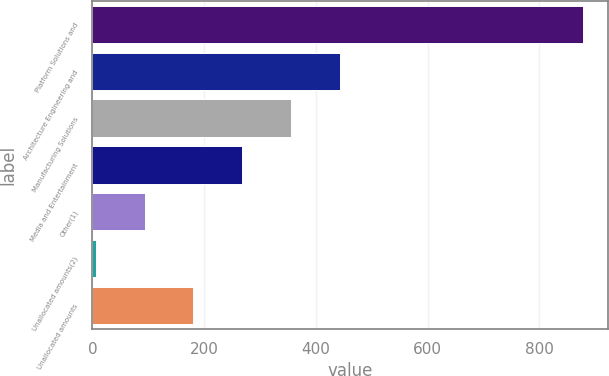<chart> <loc_0><loc_0><loc_500><loc_500><bar_chart><fcel>Platform Solutions and<fcel>Architecture Engineering and<fcel>Manufacturing Solutions<fcel>Media and Entertainment<fcel>Other(1)<fcel>Unallocated amounts(2)<fcel>Unallocated amounts<nl><fcel>878.9<fcel>442.5<fcel>355.22<fcel>267.94<fcel>93.38<fcel>6.1<fcel>180.66<nl></chart> 